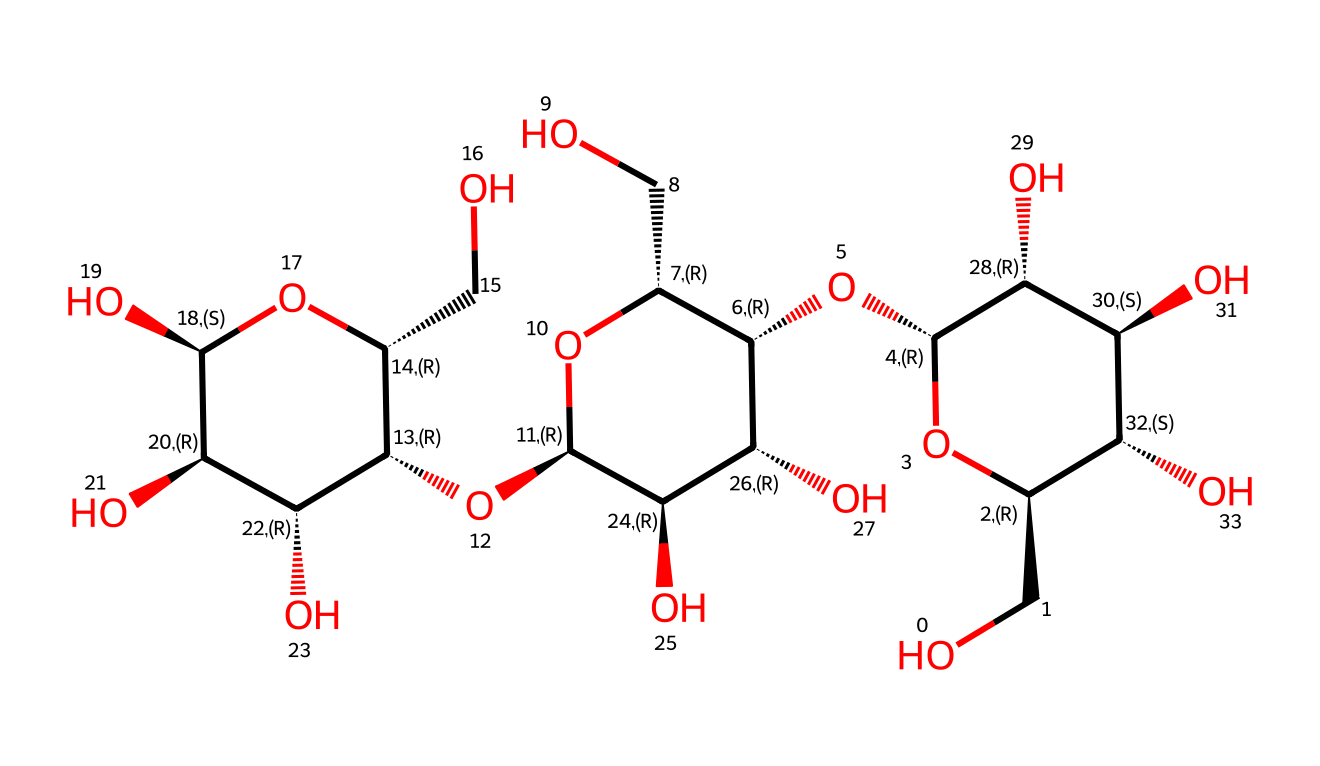What is the main repeating unit in this polymer? The structure contains glucose units that are linked together by glycosidic bonds. Each glucose unit is derived from the common plant sugar, and its repetitive nature indicates that it is a polymer.
Answer: glucose How many hydroxyl (-OH) groups are present in this molecule? The structural representation shows multiple -OH groups attached to the carbon atoms, particularly on the glucose rings. Careful counting identifies a total of 8 hydroxyl groups in the structure.
Answer: 8 What type of linkage connects the sugar units in this polymer? The linkage connecting the sugar units is known as a glycosidic bond. This is a carbohydrate polymer characteristic where the hydroxyl groups of the sugar react to form these bonds.
Answer: glycosidic What role does this polymer play in plant cell walls? Cellulose serves as a structural component of the plant cell wall, providing rigidity and strength, which is essential for maintaining plant shape and resistance to external pressures.
Answer: structural How many stereocenters are present in this molecule? Each sugar unit of glucose in the polymer structure has multiple chiral centers, and a detailed examination reveals 4 stereocenters when considering the common form of glucose.
Answer: 4 What type of polymer is cellulose categorized as? Cellulose is categorized as a homopolymer because it consists solely of repeating units of one type of monomer, which is glucose.
Answer: homopolymer 